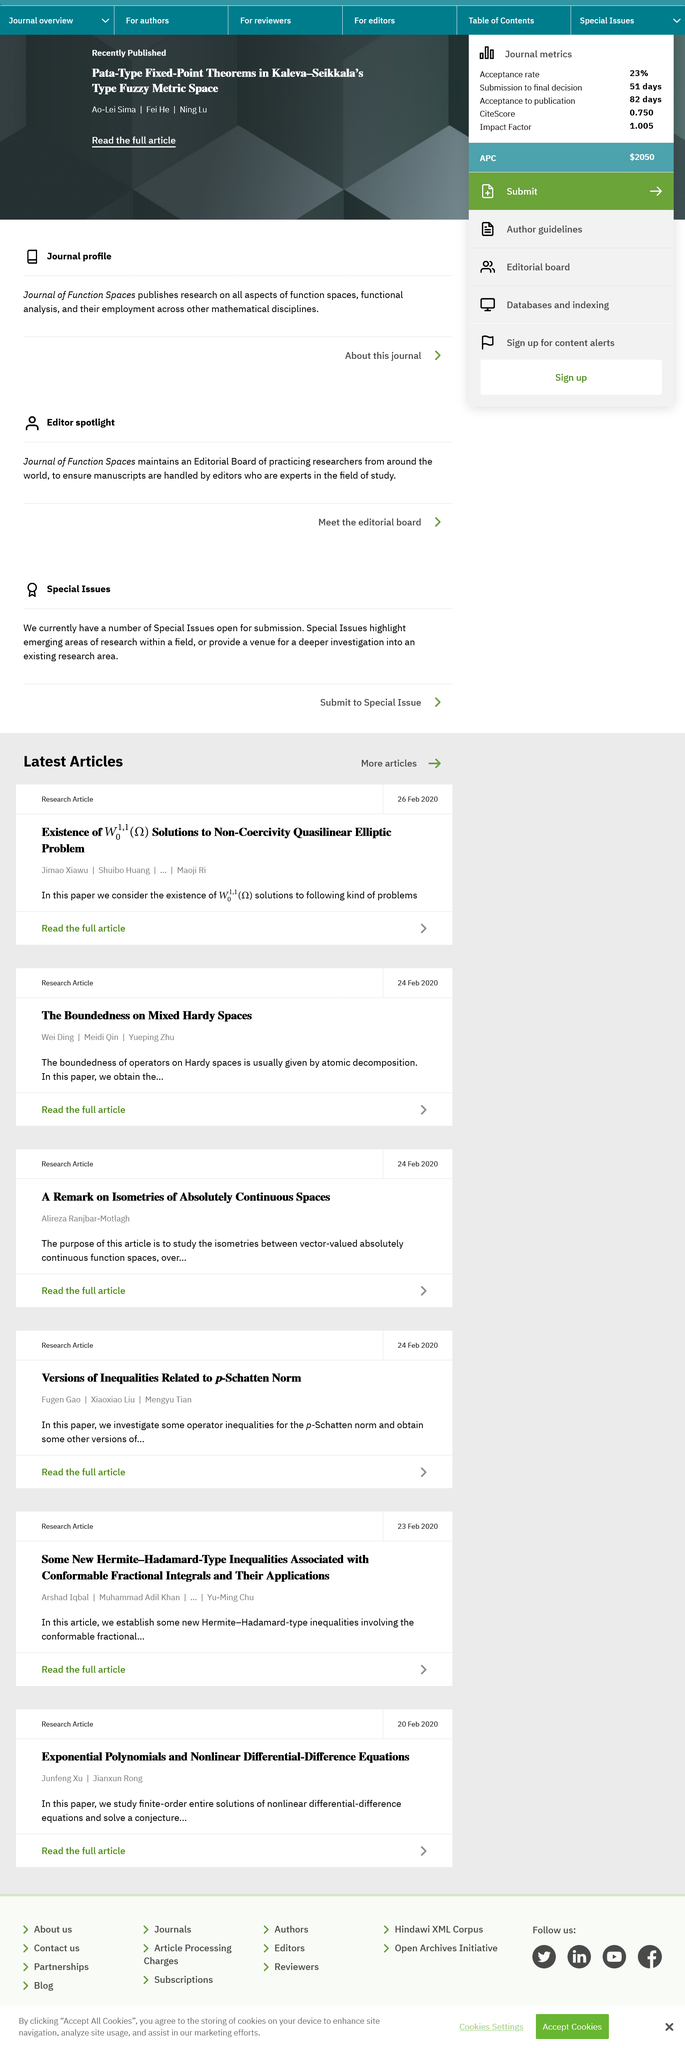Draw attention to some important aspects in this diagram. The research article titled "Versions of Inequalities Related to p-Schatten Norm" was published on February 24, 2020. The author of the article about Isometries of Absolutely Continuous Spaces is Alireza Ranjbar-Motlagh. It is possible for readers to access and read the entire article titled 'A Remark on Isometries of Absolutely Continuous Spaces.' 